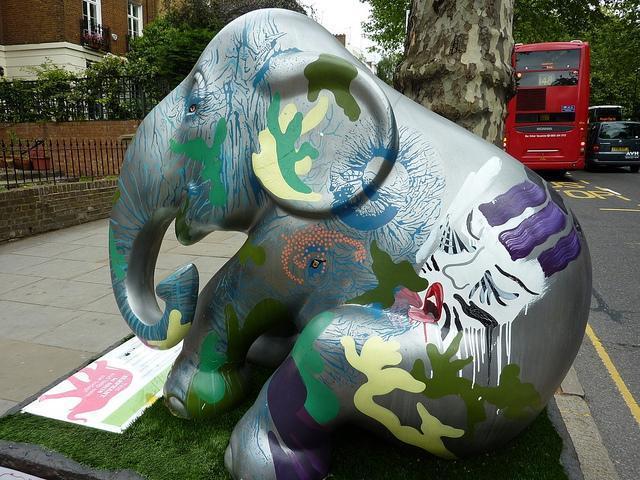Verify the accuracy of this image caption: "The bus is away from the elephant.".
Answer yes or no. Yes. Does the description: "The elephant is in front of the bus." accurately reflect the image?
Answer yes or no. No. Does the image validate the caption "The bus is in front of the elephant."?
Answer yes or no. No. Is "The elephant is facing away from the bus." an appropriate description for the image?
Answer yes or no. Yes. 